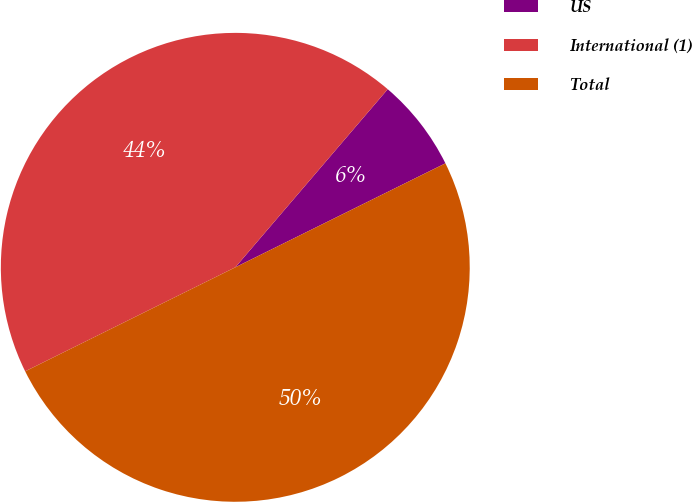Convert chart. <chart><loc_0><loc_0><loc_500><loc_500><pie_chart><fcel>US<fcel>International (1)<fcel>Total<nl><fcel>6.42%<fcel>43.58%<fcel>50.0%<nl></chart> 